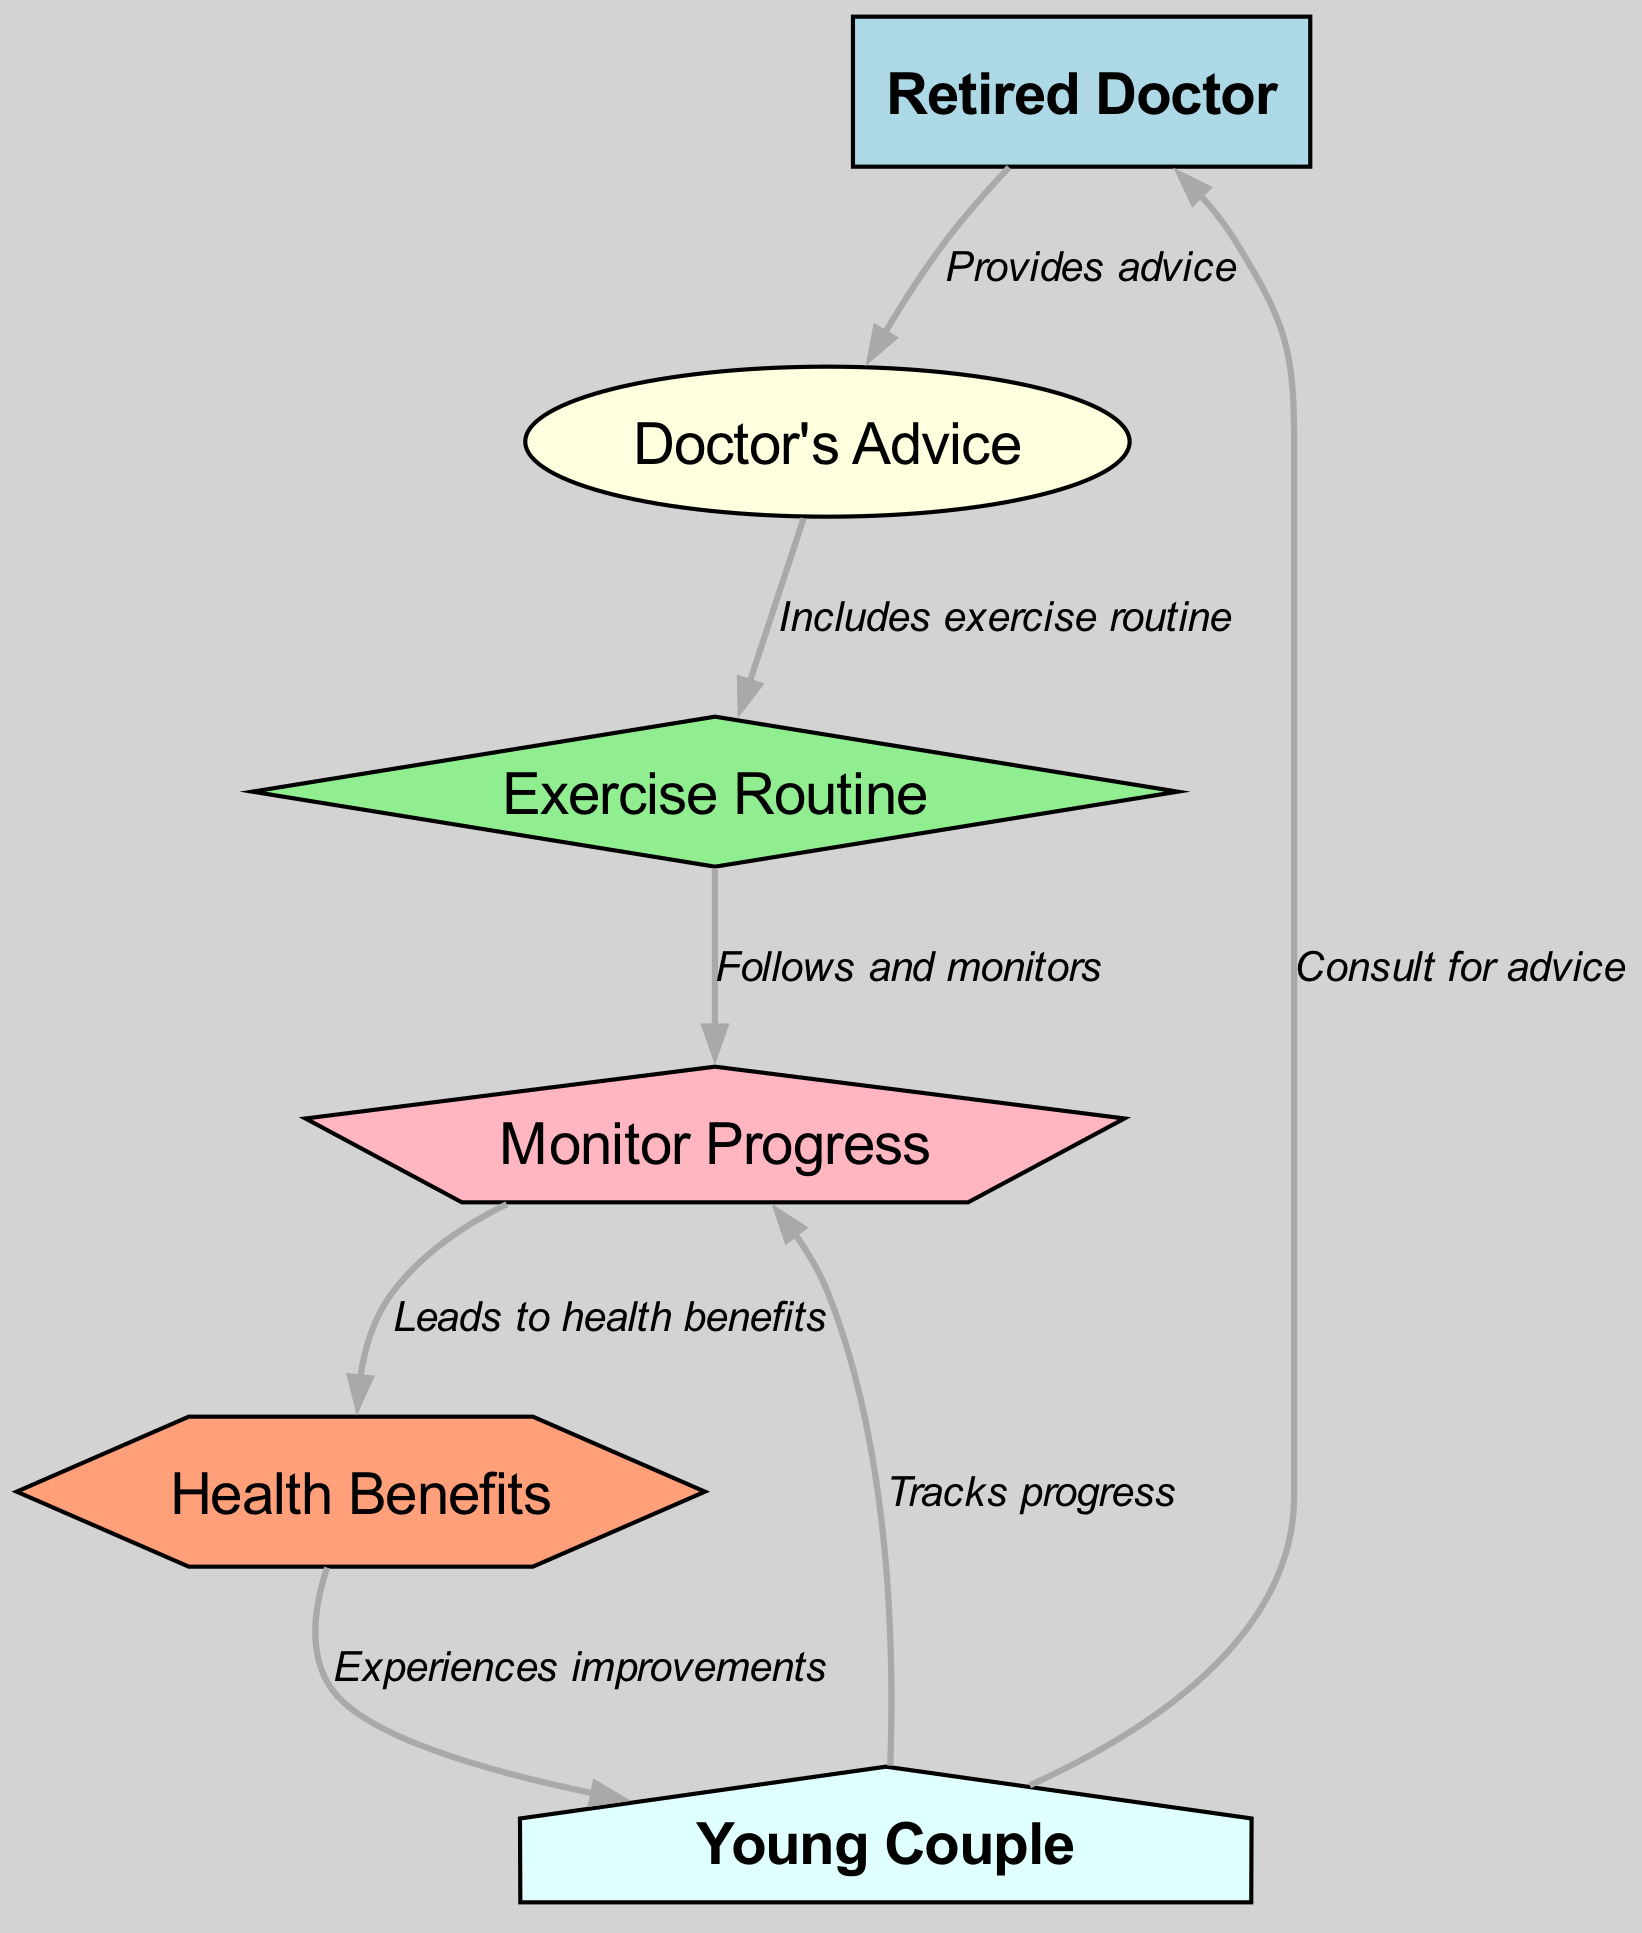What is the total number of nodes in the diagram? Counting the nodes listed in the diagram data, we have six nodes: Retired Doctor, Doctor's Advice, Exercise Routine, Monitor Progress, Health Benefits, and Young Couple.
Answer: 6 What is the label of the node that follows 'Doctor's Advice'? Reviewing the edges, the direct connection from 'Doctor's Advice' leads to 'Exercise Routine'. This indicates that 'Exercise Routine' is the next node.
Answer: Exercise Routine Who does the young couple consult for advice? The diagram shows a directed edge from 'Young Couple' to 'Doctor', which indicates that they consult the 'Retired Doctor' for advice.
Answer: Retired Doctor What is the shape of the node representing 'Health Benefits'? From the diagram specifications, the node labeled 'Health Benefits' is defined to have a hexagon shape.
Answer: Hexagon Which node represents the action of following and monitoring? The edge originating from 'Exercise Routine' and leading to 'Monitor Progress' signifies that 'Monitor Progress' represents the action of following and monitoring the exercise routine.
Answer: Monitor Progress What relationship exists between 'Monitor Progress' and 'Health Benefits'? The edge connects 'Monitor Progress' to 'Health Benefits', indicating that monitoring progress leads to health benefits. Thus, there is a directional relationship from 'Monitor Progress' to 'Health Benefits'.
Answer: Leads to How does the young couple experience improvements in their health? The diagram indicates a pathway where 'Health Benefits' connects back to 'Young Couple'; hence, the benefits of their actions and monitoring lead to improvements in their health, completing the cycle of feedback.
Answer: Experiences improvements What does the exercise routine include according to the doctor's advice? The edge from 'Doctor's Advice' to 'Exercise Routine' indicates that the exercise routine is a part of the advice given by the doctor. Thus, it includes an exercise routine as stated.
Answer: Exercise routine How are progress monitored by the young couple? The diagram depicts a direct connection from 'Young Couple' to 'Monitor Progress', suggesting that they actively track and monitor their progress as part of their routine.
Answer: Tracks progress What shape is used to represent the 'Exercise Routine'? According to the node styles specified in the diagram, the 'Exercise Routine' is represented by a diamond shape.
Answer: Diamond 